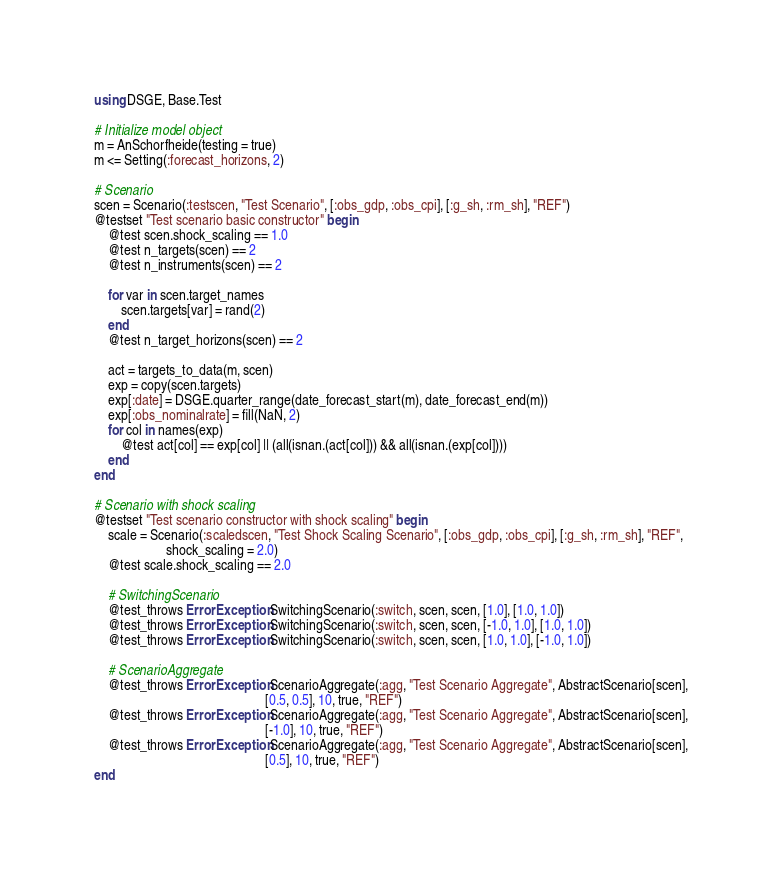<code> <loc_0><loc_0><loc_500><loc_500><_Julia_>using DSGE, Base.Test

# Initialize model object
m = AnSchorfheide(testing = true)
m <= Setting(:forecast_horizons, 2)

# Scenario
scen = Scenario(:testscen, "Test Scenario", [:obs_gdp, :obs_cpi], [:g_sh, :rm_sh], "REF")
@testset "Test scenario basic constructor" begin
    @test scen.shock_scaling == 1.0
    @test n_targets(scen) == 2
    @test n_instruments(scen) == 2

    for var in scen.target_names
        scen.targets[var] = rand(2)
    end
    @test n_target_horizons(scen) == 2

    act = targets_to_data(m, scen)
    exp = copy(scen.targets)
    exp[:date] = DSGE.quarter_range(date_forecast_start(m), date_forecast_end(m))
    exp[:obs_nominalrate] = fill(NaN, 2)
    for col in names(exp)
        @test act[col] == exp[col] || (all(isnan.(act[col])) && all(isnan.(exp[col])))
    end
end

# Scenario with shock scaling
@testset "Test scenario constructor with shock scaling" begin
    scale = Scenario(:scaledscen, "Test Shock Scaling Scenario", [:obs_gdp, :obs_cpi], [:g_sh, :rm_sh], "REF",
                     shock_scaling = 2.0)
    @test scale.shock_scaling == 2.0

    # SwitchingScenario
    @test_throws ErrorException SwitchingScenario(:switch, scen, scen, [1.0], [1.0, 1.0])
    @test_throws ErrorException SwitchingScenario(:switch, scen, scen, [-1.0, 1.0], [1.0, 1.0])
    @test_throws ErrorException SwitchingScenario(:switch, scen, scen, [1.0, 1.0], [-1.0, 1.0])

    # ScenarioAggregate
    @test_throws ErrorException ScenarioAggregate(:agg, "Test Scenario Aggregate", AbstractScenario[scen],
                                                  [0.5, 0.5], 10, true, "REF")
    @test_throws ErrorException ScenarioAggregate(:agg, "Test Scenario Aggregate", AbstractScenario[scen],
                                                  [-1.0], 10, true, "REF")
    @test_throws ErrorException ScenarioAggregate(:agg, "Test Scenario Aggregate", AbstractScenario[scen],
                                                  [0.5], 10, true, "REF")
end
</code> 